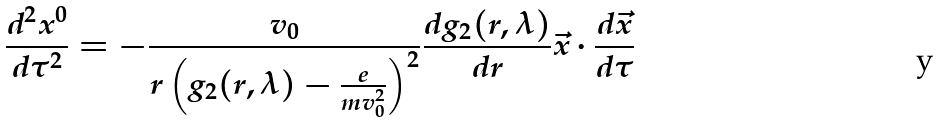<formula> <loc_0><loc_0><loc_500><loc_500>\frac { d ^ { 2 } x ^ { 0 } } { d \tau ^ { 2 } } = - \frac { v _ { 0 } } { r \left ( g _ { 2 } ( r , \lambda ) - \frac { e } { m v _ { 0 } ^ { 2 } } \right ) ^ { 2 } } \frac { d g _ { 2 } ( r , \lambda ) } { d r } \vec { x } \cdot \frac { d \vec { x } } { d \tau }</formula> 